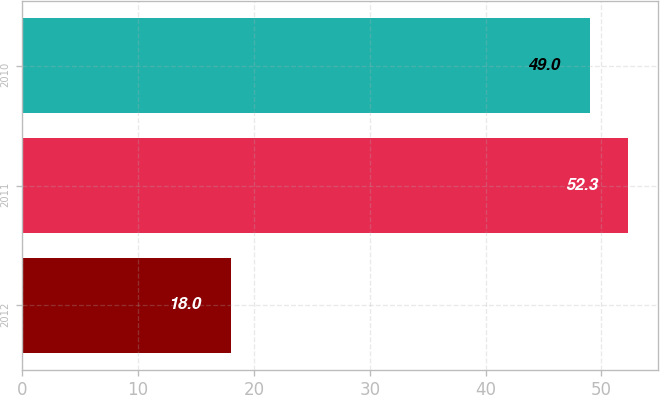<chart> <loc_0><loc_0><loc_500><loc_500><bar_chart><fcel>2012<fcel>2011<fcel>2010<nl><fcel>18<fcel>52.3<fcel>49<nl></chart> 